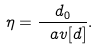Convert formula to latex. <formula><loc_0><loc_0><loc_500><loc_500>\eta = \frac { d _ { 0 } } { \ a v [ d ] } .</formula> 